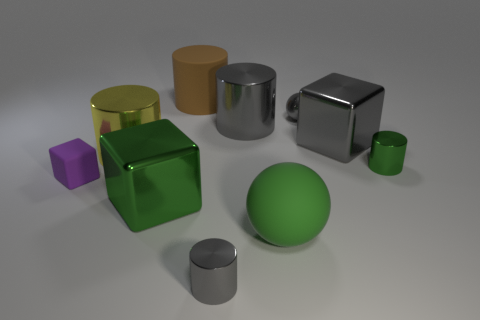Does the yellow cylinder that is to the left of the green cube have the same size as the big brown cylinder?
Make the answer very short. Yes. There is a shiny object that is both in front of the gray shiny ball and behind the gray cube; what size is it?
Your answer should be very brief. Large. There is a tiny thing that is the same color as the large sphere; what is its material?
Offer a terse response. Metal. What number of shiny cubes have the same color as the big ball?
Your answer should be compact. 1. Is the number of brown rubber things that are in front of the gray metal ball the same as the number of rubber spheres?
Your answer should be very brief. No. What color is the rubber sphere?
Keep it short and to the point. Green. There is a yellow object that is made of the same material as the large gray block; what is its size?
Provide a succinct answer. Large. What color is the other big object that is made of the same material as the brown object?
Give a very brief answer. Green. Is there a matte object that has the same size as the green cylinder?
Give a very brief answer. Yes. There is a large gray object that is the same shape as the small green thing; what material is it?
Keep it short and to the point. Metal. 